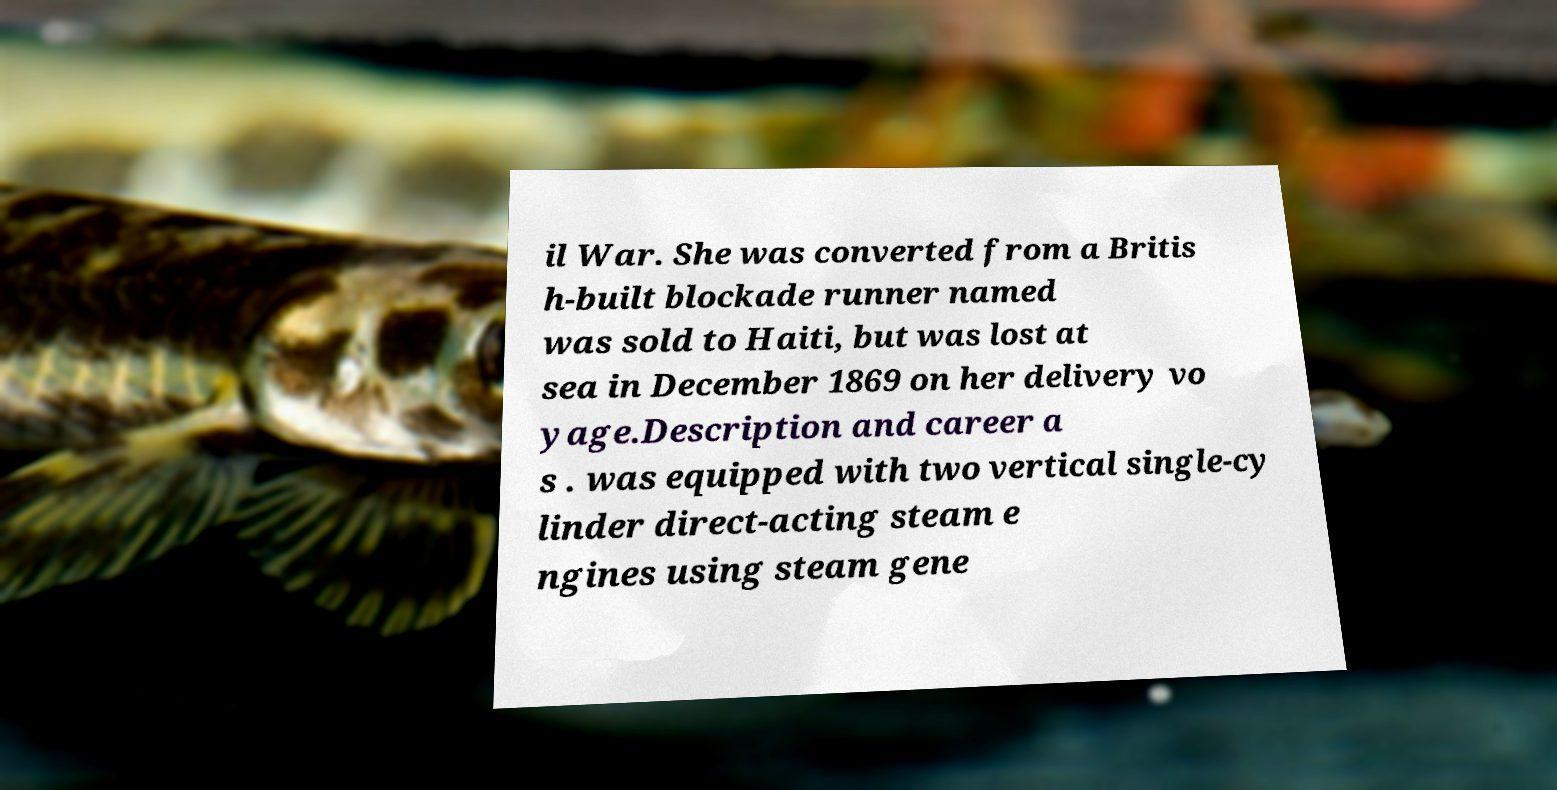There's text embedded in this image that I need extracted. Can you transcribe it verbatim? il War. She was converted from a Britis h-built blockade runner named was sold to Haiti, but was lost at sea in December 1869 on her delivery vo yage.Description and career a s . was equipped with two vertical single-cy linder direct-acting steam e ngines using steam gene 